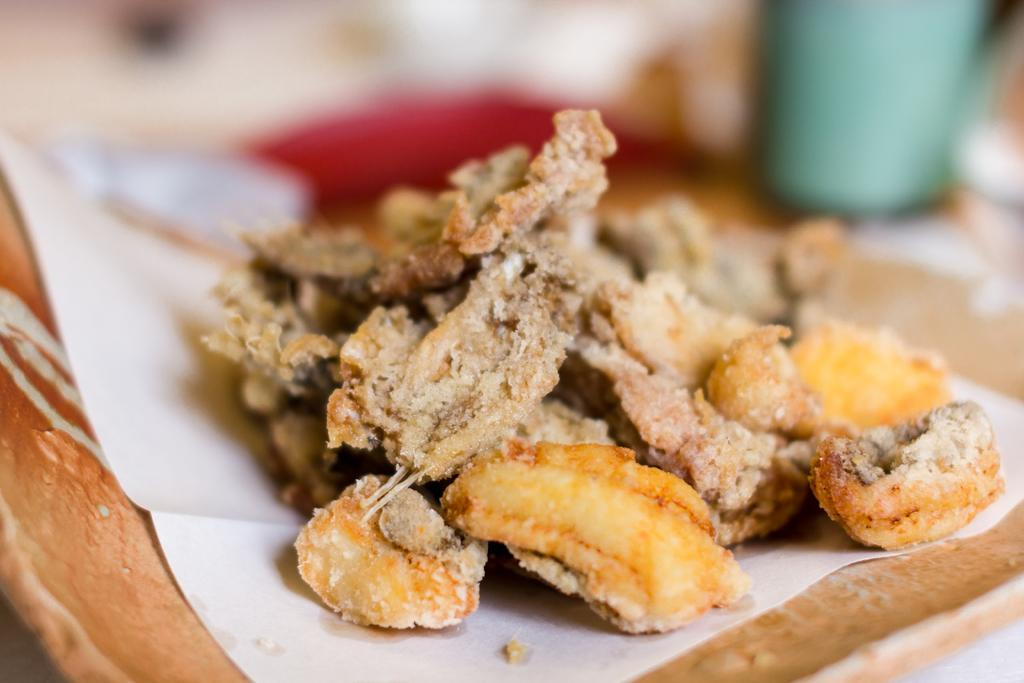What is present in the image that people typically consume? There is food in the image. What type of disposable item can be seen in the image? There is a tissue paper in the image. Where is the tissue paper located? The tissue paper is in a plate. Can you describe the background of the image? The background of the image is blurry. What type of mountain can be seen in the background of the image? There is no mountain present in the image; the background is blurry. What kind of animal is interacting with the food in the image? There is no animal present in the image; it only features food and tissue paper. 